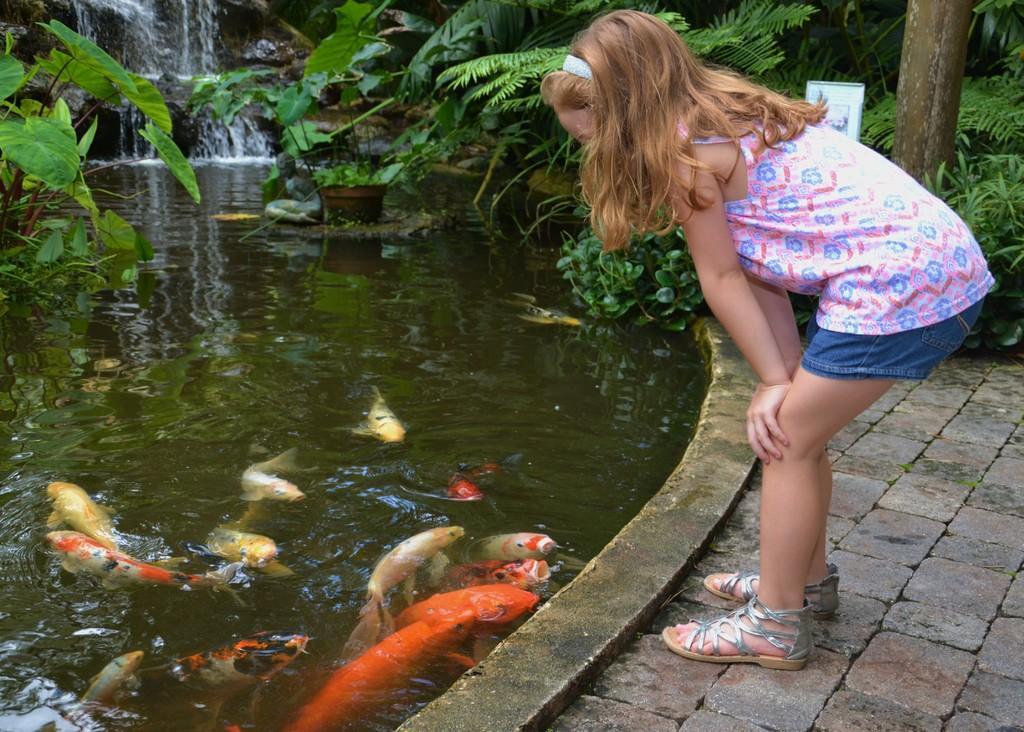Who is the main subject in the image? There is a small girl in the image. Where is the girl positioned in relation to the other elements in the image? The girl is standing in the front. What is the girl doing in the image? The girl is watching koi fish. Where are the koi fish located? The koi fish are in a small pond. What else can be seen in the image besides the girl and the koi fish? There are plants visible in the image. What color are the eyes of the tiger in the image? There is no tiger present in the image; it features a small girl watching koi fish in a pond. Are there any fairies visible in the image? There are no fairies present in the image; it features a small girl watching koi fish in a pond. 